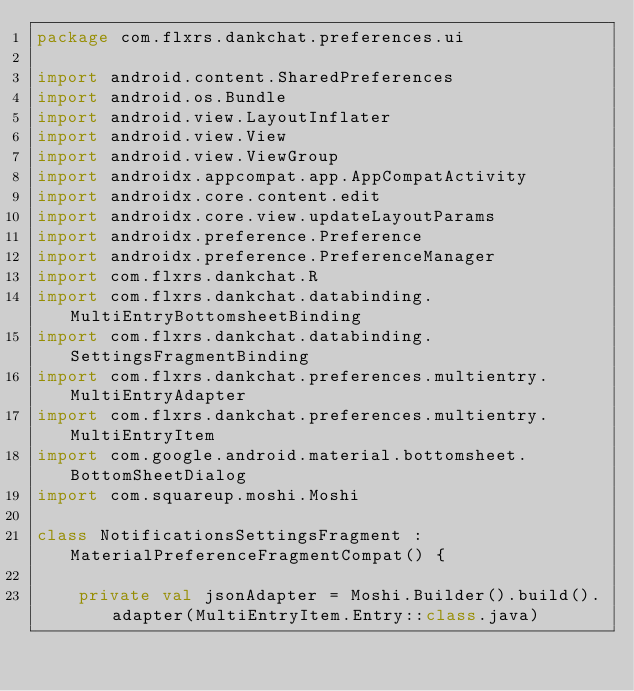Convert code to text. <code><loc_0><loc_0><loc_500><loc_500><_Kotlin_>package com.flxrs.dankchat.preferences.ui

import android.content.SharedPreferences
import android.os.Bundle
import android.view.LayoutInflater
import android.view.View
import android.view.ViewGroup
import androidx.appcompat.app.AppCompatActivity
import androidx.core.content.edit
import androidx.core.view.updateLayoutParams
import androidx.preference.Preference
import androidx.preference.PreferenceManager
import com.flxrs.dankchat.R
import com.flxrs.dankchat.databinding.MultiEntryBottomsheetBinding
import com.flxrs.dankchat.databinding.SettingsFragmentBinding
import com.flxrs.dankchat.preferences.multientry.MultiEntryAdapter
import com.flxrs.dankchat.preferences.multientry.MultiEntryItem
import com.google.android.material.bottomsheet.BottomSheetDialog
import com.squareup.moshi.Moshi

class NotificationsSettingsFragment : MaterialPreferenceFragmentCompat() {

    private val jsonAdapter = Moshi.Builder().build().adapter(MultiEntryItem.Entry::class.java)
</code> 